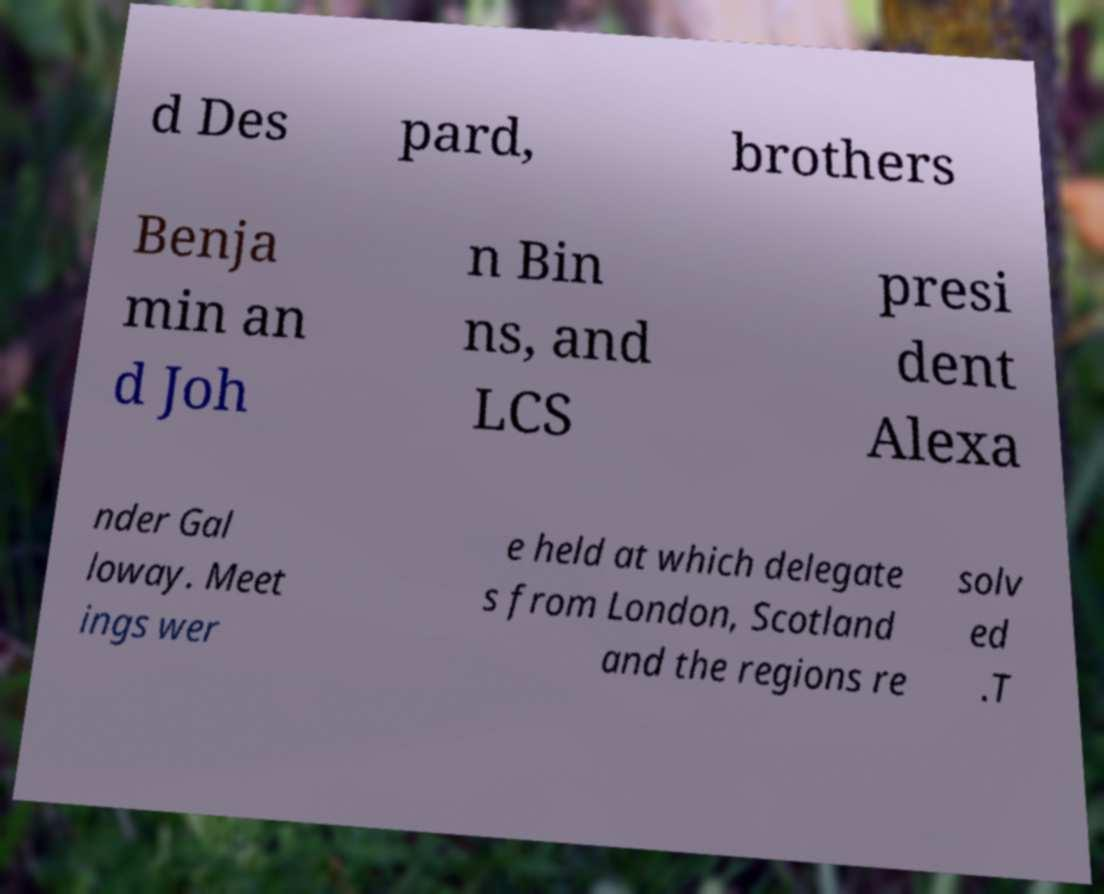Please identify and transcribe the text found in this image. d Des pard, brothers Benja min an d Joh n Bin ns, and LCS presi dent Alexa nder Gal loway. Meet ings wer e held at which delegate s from London, Scotland and the regions re solv ed .T 